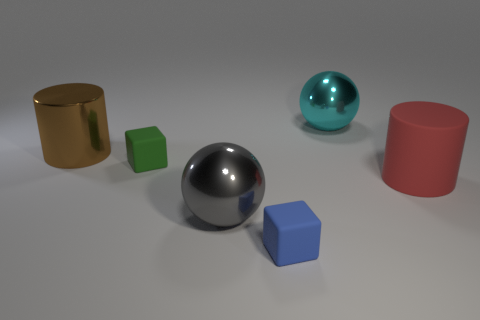Does the large red object have the same material as the sphere on the left side of the tiny blue block?
Keep it short and to the point. No. Does the cyan object have the same shape as the large red object?
Make the answer very short. No. What is the material of the other large object that is the same shape as the large cyan shiny object?
Provide a succinct answer. Metal. What is the color of the thing that is behind the tiny green object and on the left side of the gray object?
Provide a succinct answer. Brown. The shiny cylinder has what color?
Your answer should be very brief. Brown. Are there any tiny green matte things that have the same shape as the large cyan thing?
Give a very brief answer. No. What size is the metallic ball that is behind the brown cylinder?
Your answer should be very brief. Large. There is a block that is the same size as the green rubber thing; what is its material?
Ensure brevity in your answer.  Rubber. Is the number of large brown shiny cylinders greater than the number of shiny balls?
Make the answer very short. No. What is the size of the matte thing that is to the right of the cube on the right side of the small green object?
Provide a succinct answer. Large. 